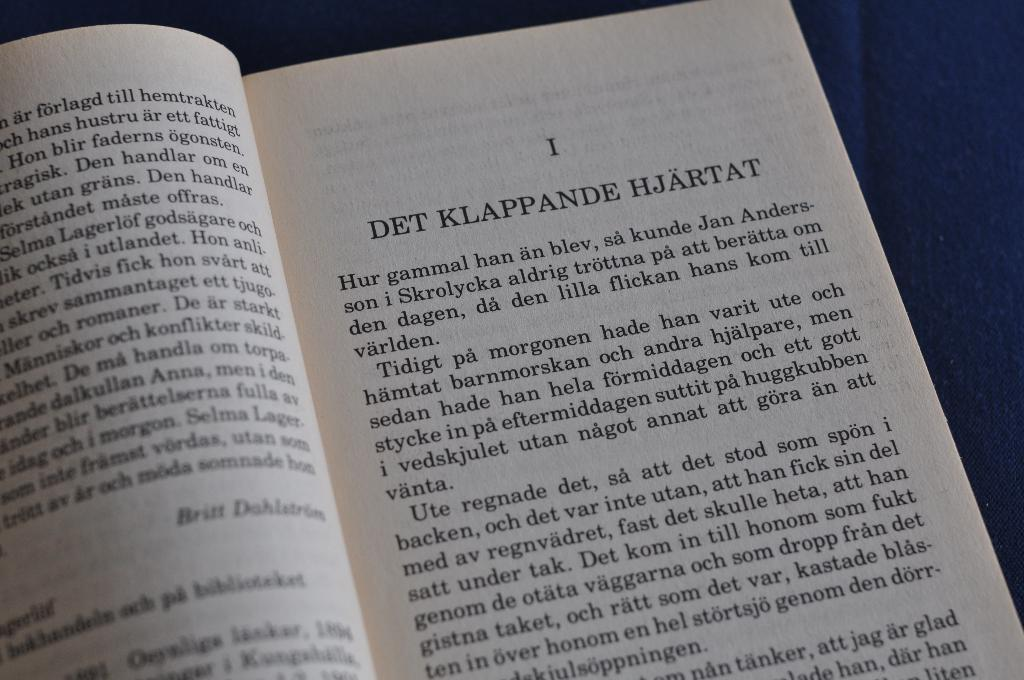<image>
Summarize the visual content of the image. A page in a book with the chapter One title DET KLAPPER HJARTAT. 